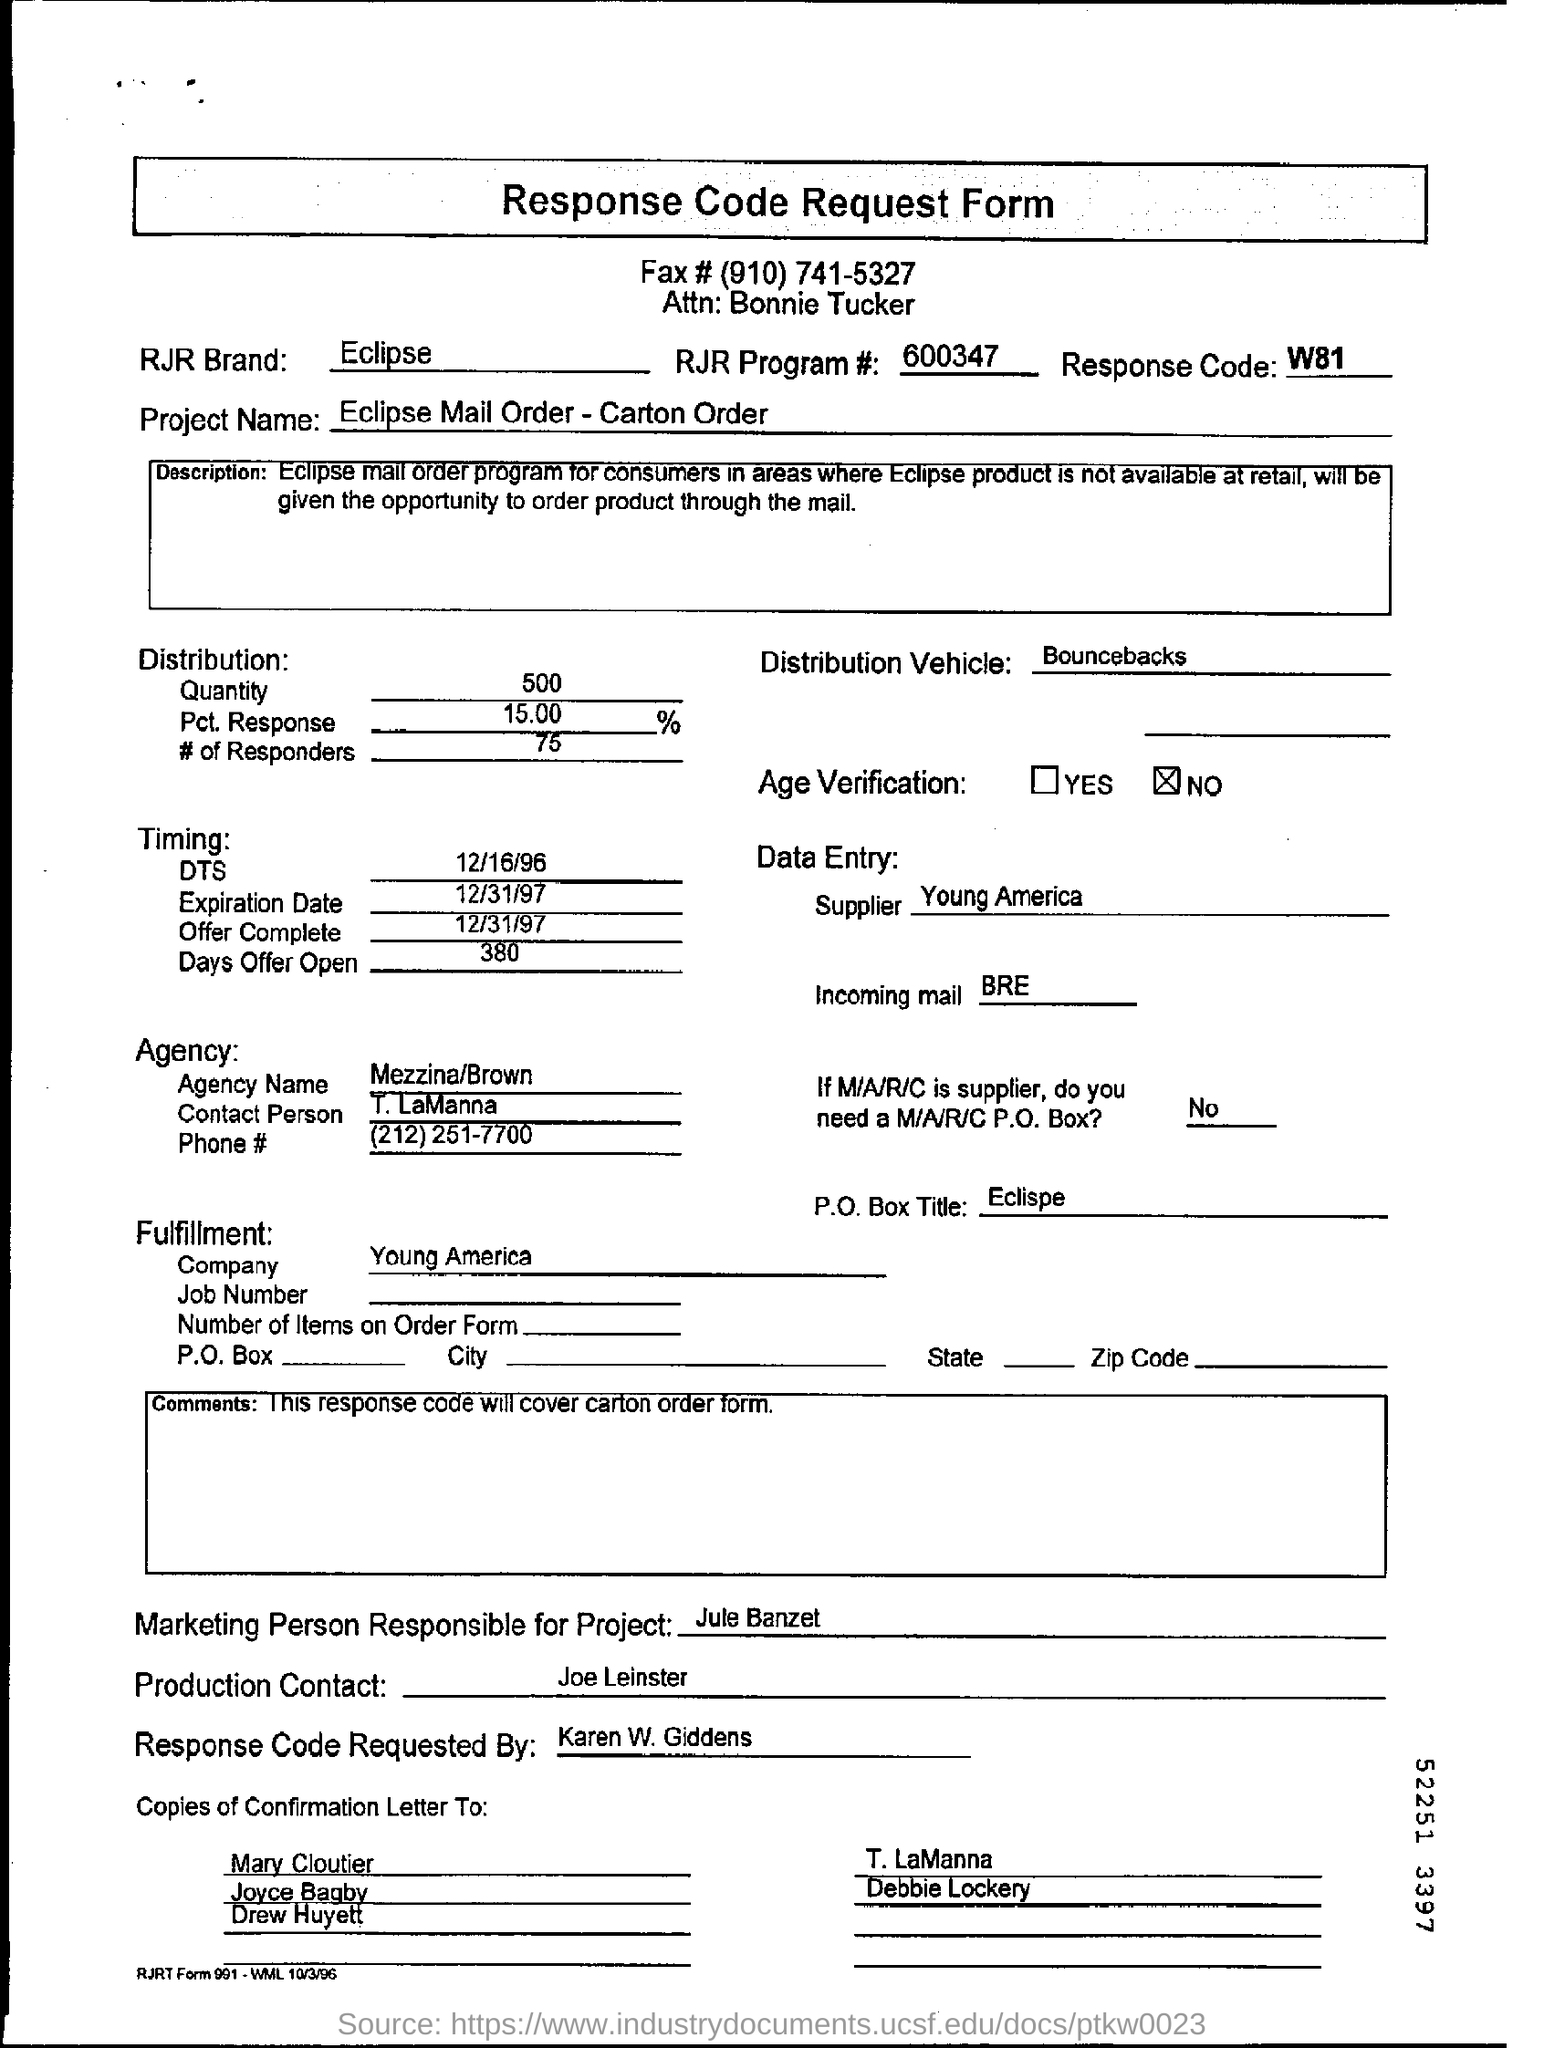What is the Project Name ?
Your answer should be very brief. Eclipse Mail Order - Carton Order. Who is the marketing person responsible for this project?
Give a very brief answer. Jule Banzet. What is the Response code ?
Make the answer very short. W81. Who is the supplier ?
Your answer should be very brief. Young America. 